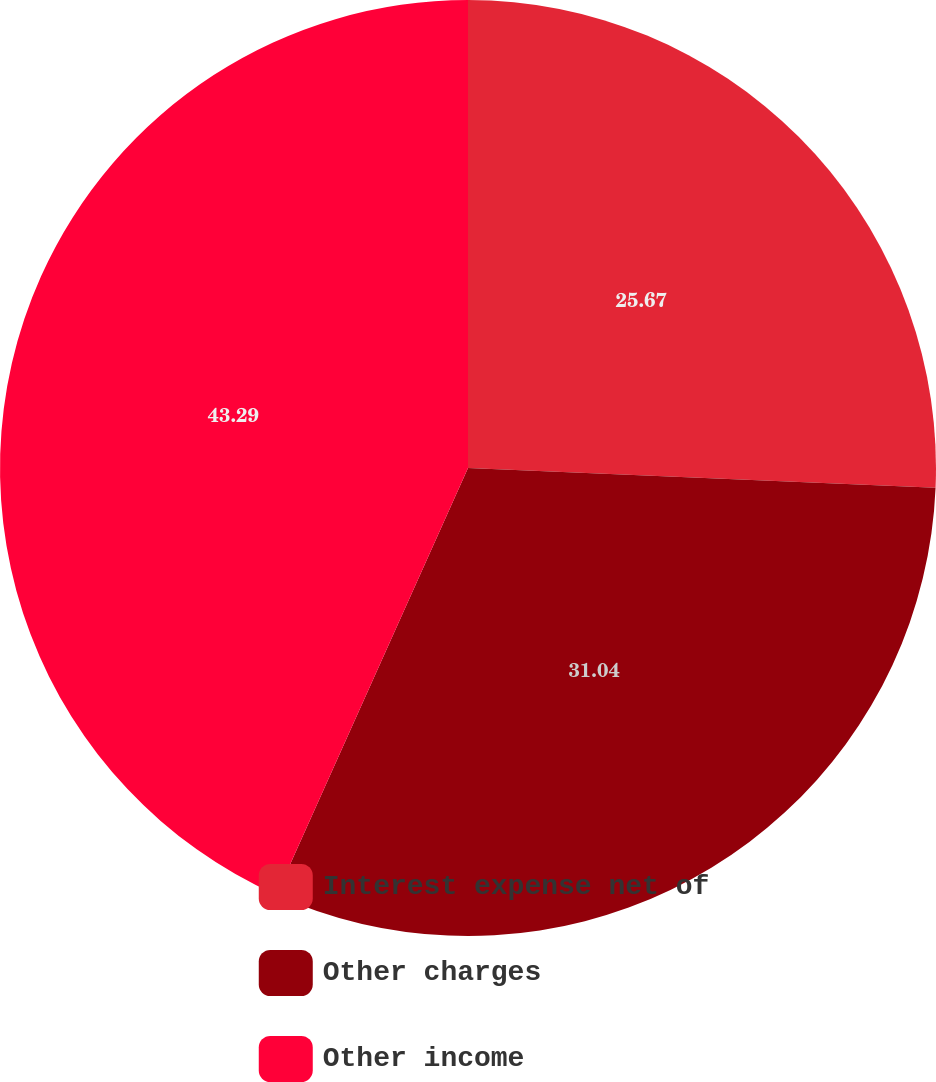Convert chart. <chart><loc_0><loc_0><loc_500><loc_500><pie_chart><fcel>Interest expense net of<fcel>Other charges<fcel>Other income<nl><fcel>25.67%<fcel>31.04%<fcel>43.28%<nl></chart> 